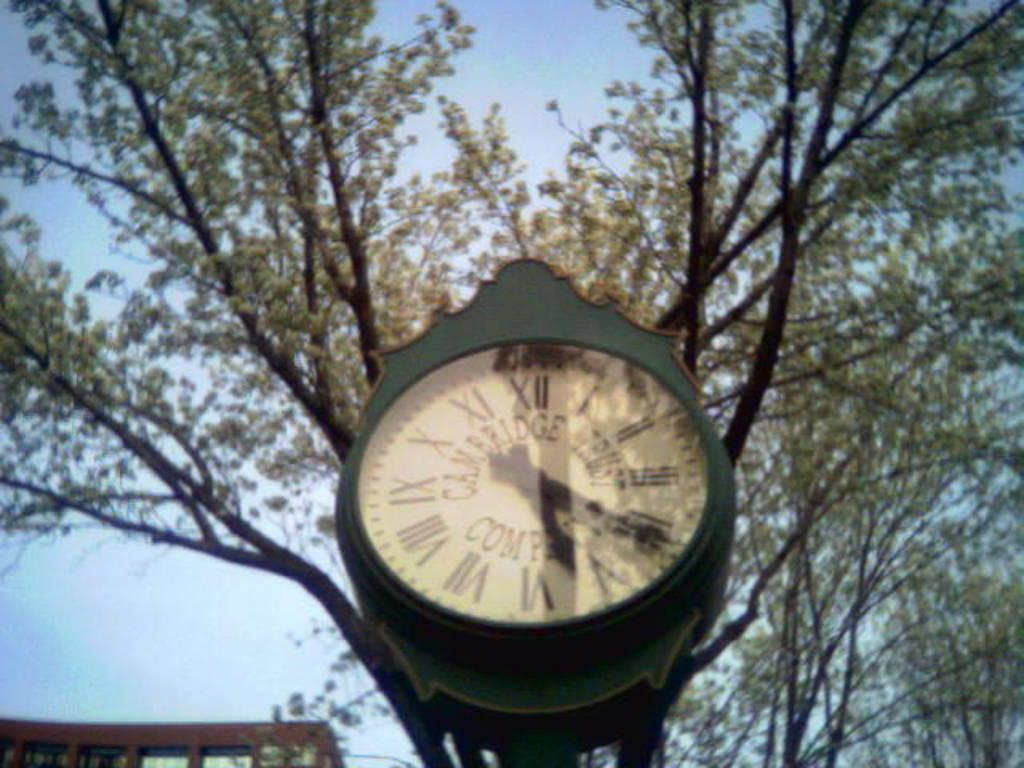<image>
Offer a succinct explanation of the picture presented. Cambridge trust company clock that is green and roman numerals 